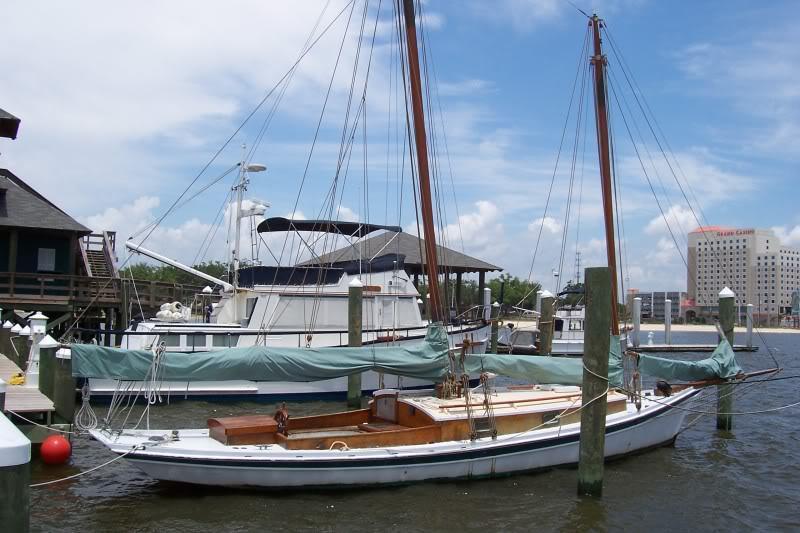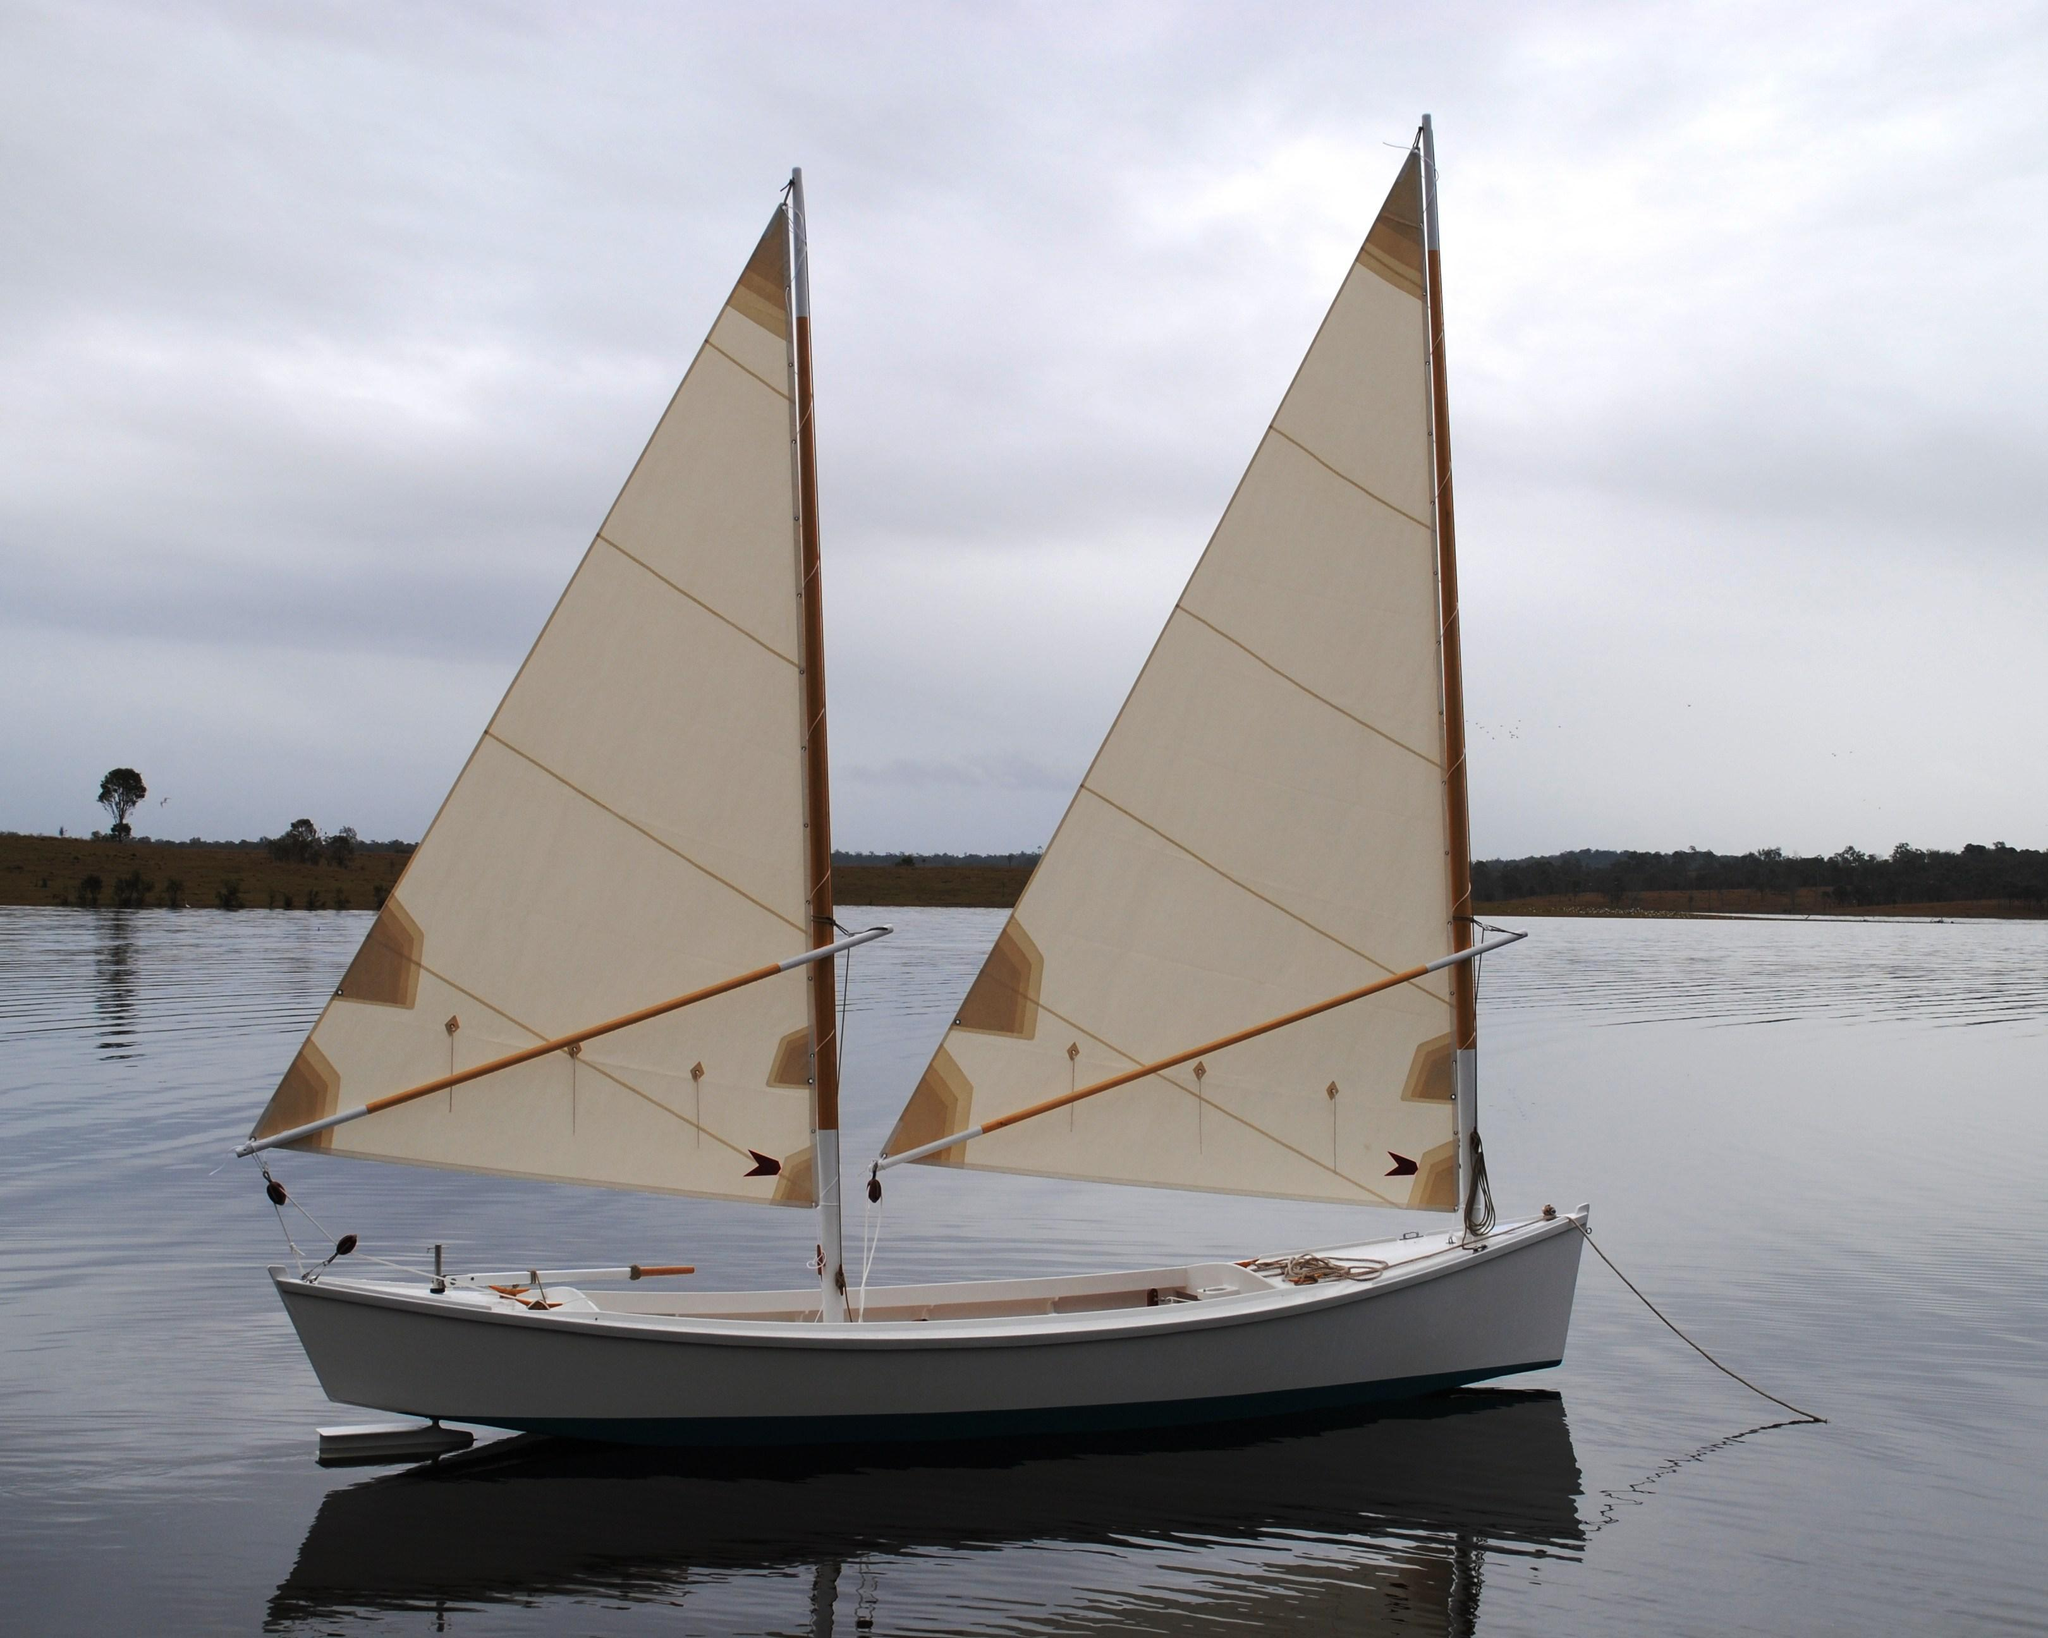The first image is the image on the left, the second image is the image on the right. Analyze the images presented: Is the assertion "At least one boat is docked near a building in one of the images." valid? Answer yes or no. Yes. The first image is the image on the left, the second image is the image on the right. For the images displayed, is the sentence "There is at least one human onboard each boat." factually correct? Answer yes or no. No. 